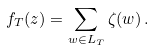<formula> <loc_0><loc_0><loc_500><loc_500>f _ { T } ( z ) = \sum _ { w \in L _ { T } } \zeta ( w ) \, .</formula> 